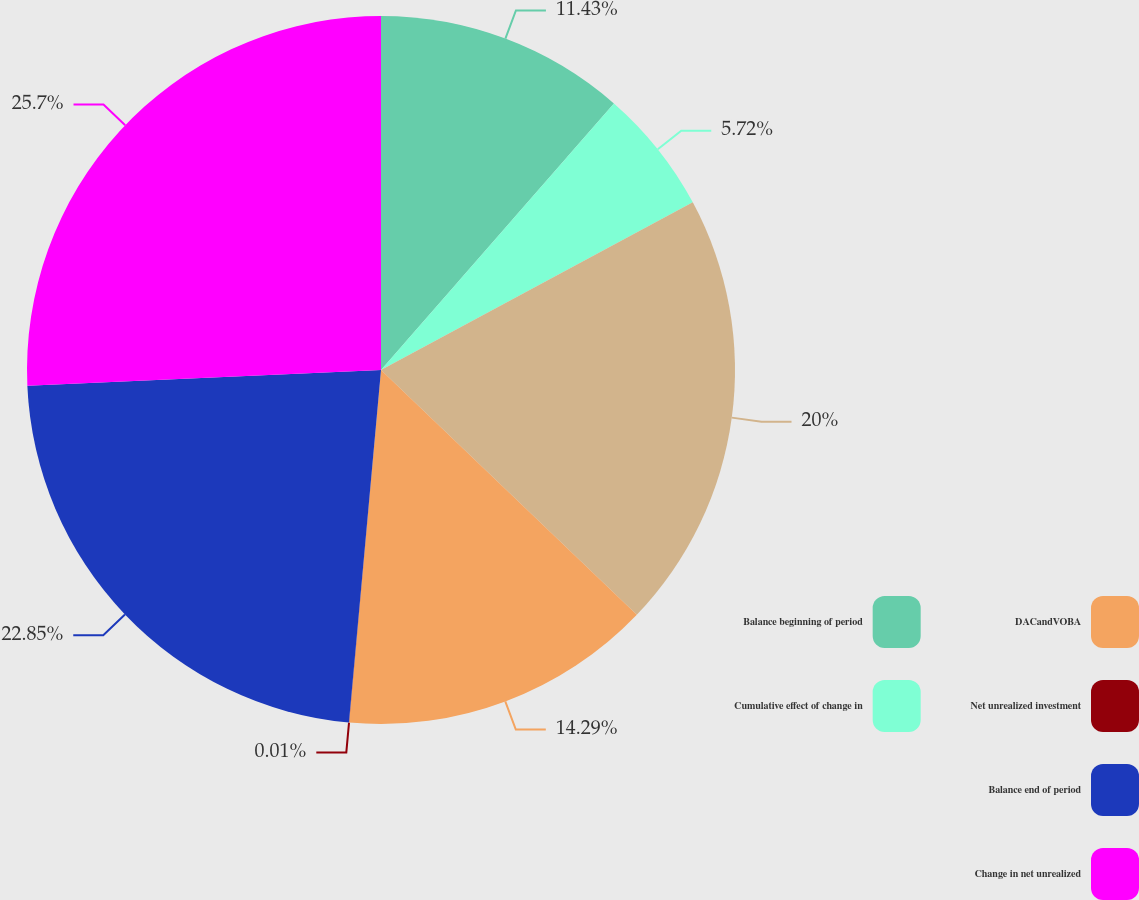<chart> <loc_0><loc_0><loc_500><loc_500><pie_chart><fcel>Balance beginning of period<fcel>Cumulative effect of change in<fcel>Unnamed: 2<fcel>DACandVOBA<fcel>Net unrealized investment<fcel>Balance end of period<fcel>Change in net unrealized<nl><fcel>11.43%<fcel>5.72%<fcel>20.0%<fcel>14.29%<fcel>0.01%<fcel>22.85%<fcel>25.71%<nl></chart> 